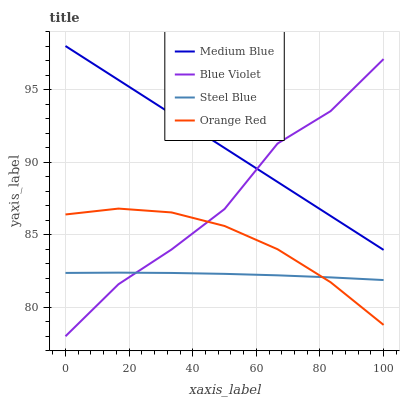Does Steel Blue have the minimum area under the curve?
Answer yes or no. Yes. Does Medium Blue have the maximum area under the curve?
Answer yes or no. Yes. Does Blue Violet have the minimum area under the curve?
Answer yes or no. No. Does Blue Violet have the maximum area under the curve?
Answer yes or no. No. Is Medium Blue the smoothest?
Answer yes or no. Yes. Is Blue Violet the roughest?
Answer yes or no. Yes. Is Steel Blue the smoothest?
Answer yes or no. No. Is Steel Blue the roughest?
Answer yes or no. No. Does Steel Blue have the lowest value?
Answer yes or no. No. Does Blue Violet have the highest value?
Answer yes or no. No. Is Orange Red less than Medium Blue?
Answer yes or no. Yes. Is Medium Blue greater than Orange Red?
Answer yes or no. Yes. Does Orange Red intersect Medium Blue?
Answer yes or no. No. 